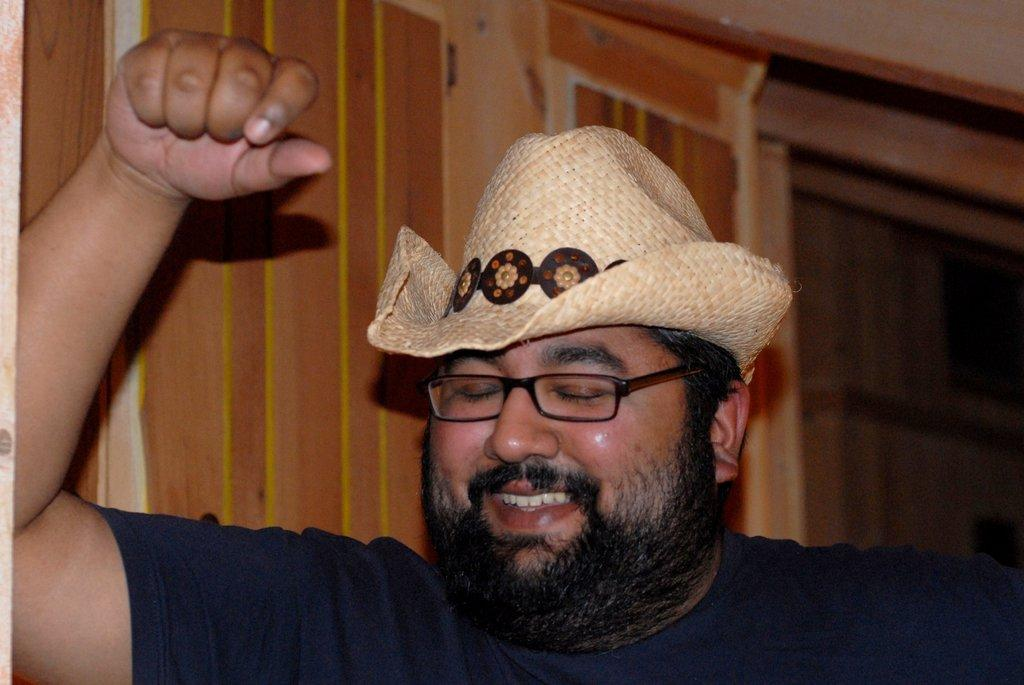What is the main subject of the image? The main subject of the image is a man. What is the man doing in the image? The man is standing in the image. Can you describe the man's attire? The man is wearing a cap and spectacles. What can be seen in the background of the image? There is a door and a wall in the background of the image. What type of butter is the man holding in the image? There is no butter present in the image; the man is not holding any butter. 